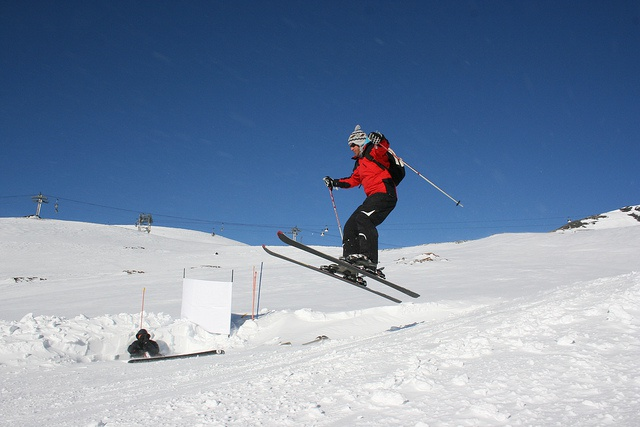Describe the objects in this image and their specific colors. I can see people in navy, black, blue, red, and gray tones, skis in navy, gray, lightgray, black, and darkgray tones, and backpack in navy, black, blue, gray, and maroon tones in this image. 